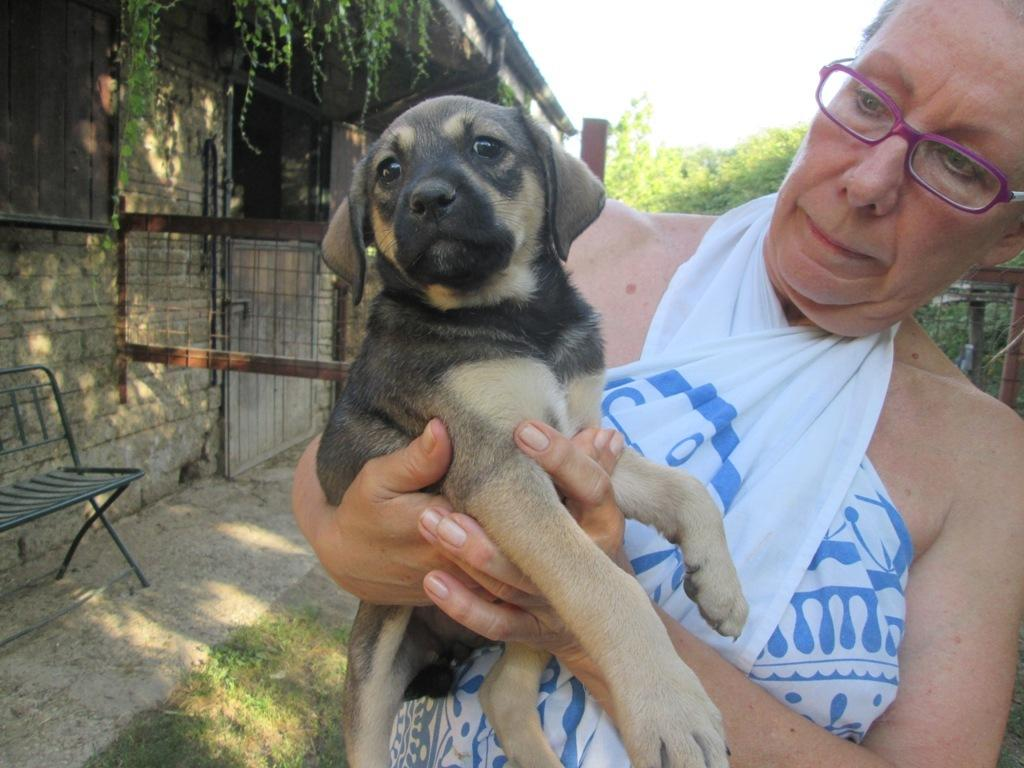What is the person in the image holding? The person is holding an animal in the image. What type of terrain is visible in the image? There is grass visible in the image. What type of structure can be seen in the image? There is a wall in the image. What type of vegetation is present in the image? There are plants in the image. What type of barrier is present in the image? There is a fence in the image. What is visible at the top of the image? The sky is visible at the top of the image. How many trucks are parked near the person holding the animal in the image? There are no trucks present in the image. Is the area around the person holding the animal quiet or noisy in the image? The provided facts do not give any information about the noise level in the image, so we cannot answer this question. 